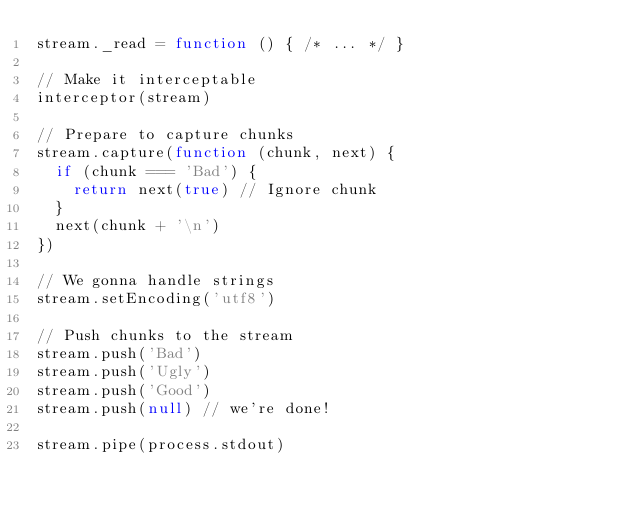Convert code to text. <code><loc_0><loc_0><loc_500><loc_500><_JavaScript_>stream._read = function () { /* ... */ }

// Make it interceptable
interceptor(stream)

// Prepare to capture chunks
stream.capture(function (chunk, next) {
  if (chunk === 'Bad') {
    return next(true) // Ignore chunk
  }
  next(chunk + '\n')
})

// We gonna handle strings
stream.setEncoding('utf8')

// Push chunks to the stream
stream.push('Bad')
stream.push('Ugly')
stream.push('Good')
stream.push(null) // we're done!

stream.pipe(process.stdout)
</code> 